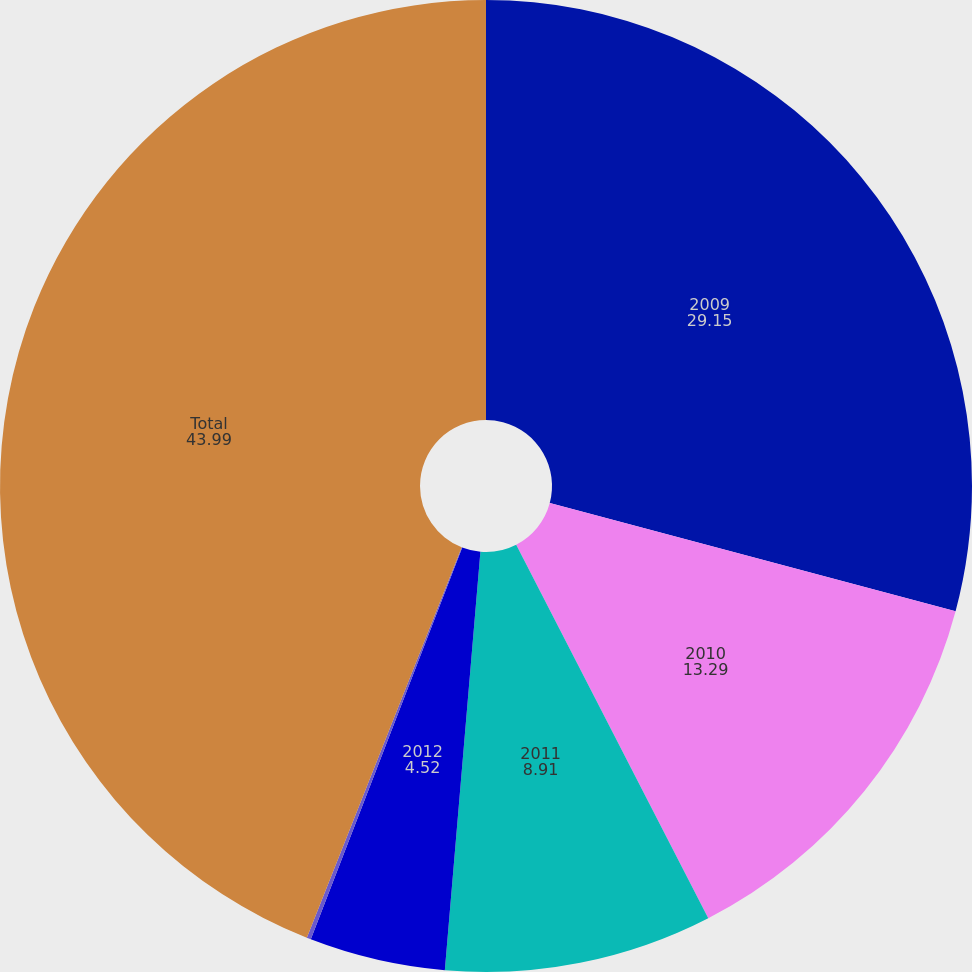<chart> <loc_0><loc_0><loc_500><loc_500><pie_chart><fcel>2009<fcel>2010<fcel>2011<fcel>2012<fcel>2013<fcel>Total<nl><fcel>29.15%<fcel>13.29%<fcel>8.91%<fcel>4.52%<fcel>0.14%<fcel>43.99%<nl></chart> 